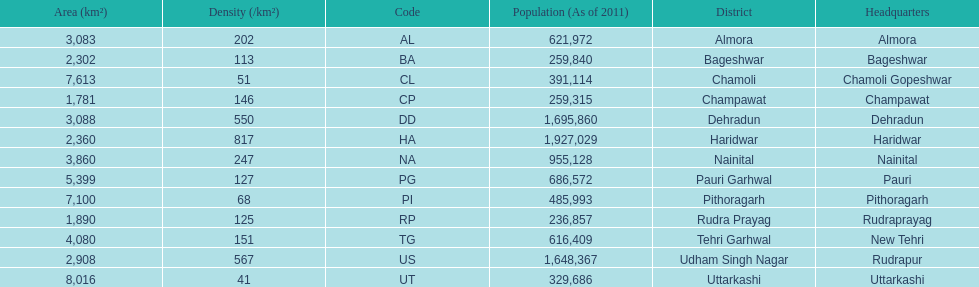What is the next most populous district after haridwar? Dehradun. 